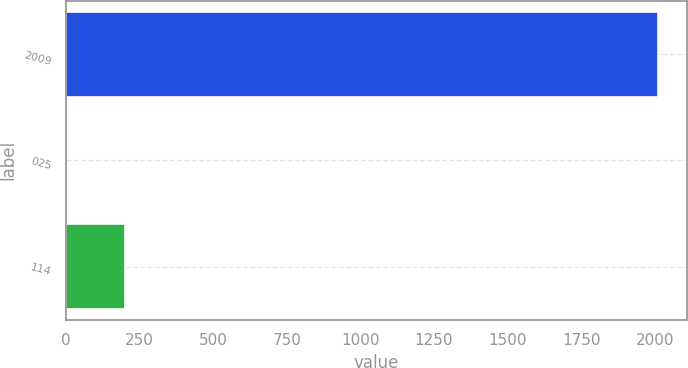Convert chart to OTSL. <chart><loc_0><loc_0><loc_500><loc_500><bar_chart><fcel>2009<fcel>025<fcel>114<nl><fcel>2009<fcel>0.25<fcel>201.12<nl></chart> 